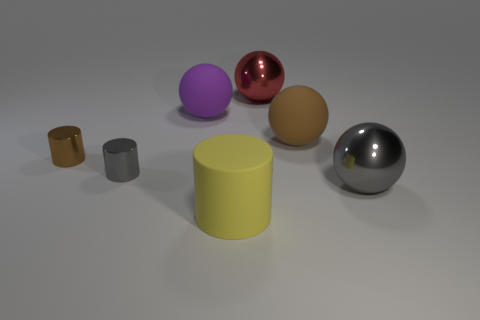Add 3 large purple spheres. How many objects exist? 10 Subtract all balls. How many objects are left? 3 Subtract all big gray metallic things. Subtract all big red shiny things. How many objects are left? 5 Add 5 small metallic cylinders. How many small metallic cylinders are left? 7 Add 7 big green cylinders. How many big green cylinders exist? 7 Subtract 0 red blocks. How many objects are left? 7 